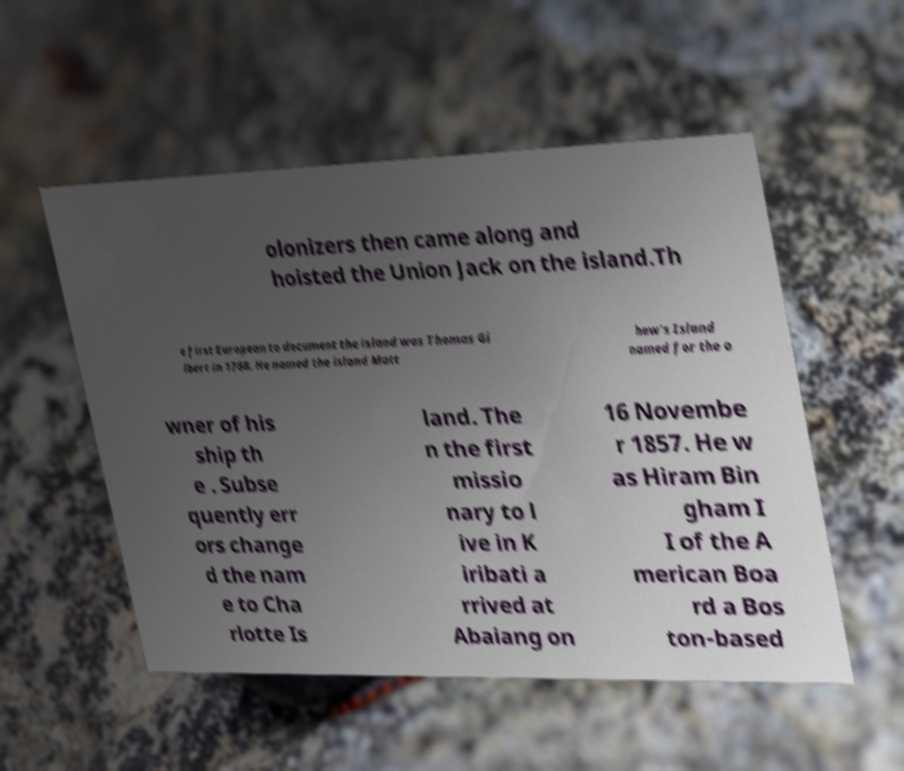What messages or text are displayed in this image? I need them in a readable, typed format. olonizers then came along and hoisted the Union Jack on the island.Th e first European to document the island was Thomas Gi lbert in 1788. He named the island Matt hew's Island named for the o wner of his ship th e . Subse quently err ors change d the nam e to Cha rlotte Is land. The n the first missio nary to l ive in K iribati a rrived at Abaiang on 16 Novembe r 1857. He w as Hiram Bin gham I I of the A merican Boa rd a Bos ton-based 